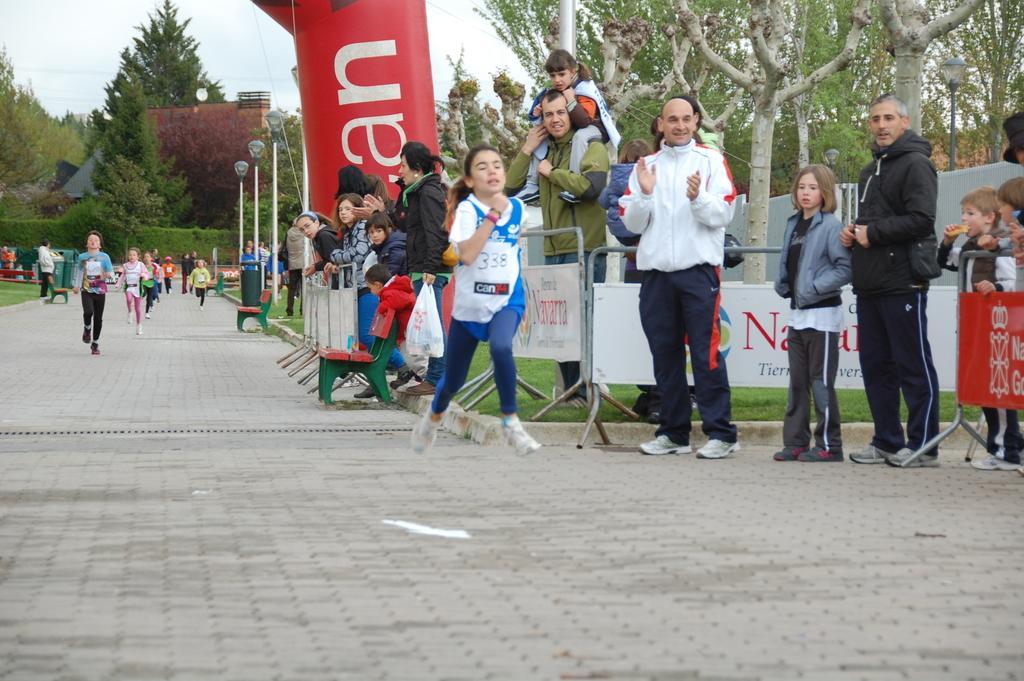In one or two sentences, can you explain what this image depicts? In the middle of the image few people are running and standing. Behind them there is a fencing and poles and banners. Behind them there are some benches and grass and dustbins. At the top of the image there is a building and trees and sky. 